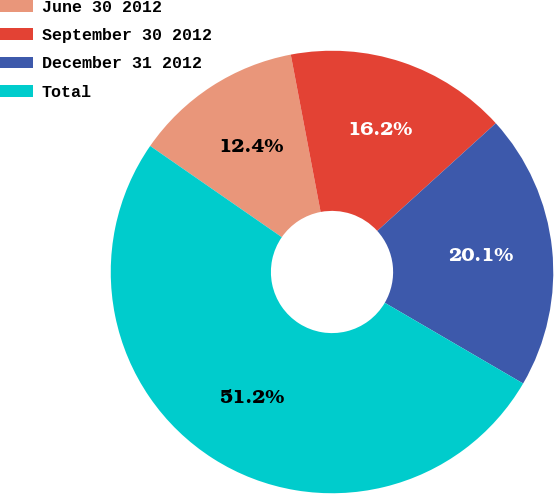<chart> <loc_0><loc_0><loc_500><loc_500><pie_chart><fcel>June 30 2012<fcel>September 30 2012<fcel>December 31 2012<fcel>Total<nl><fcel>12.37%<fcel>16.25%<fcel>20.14%<fcel>51.24%<nl></chart> 